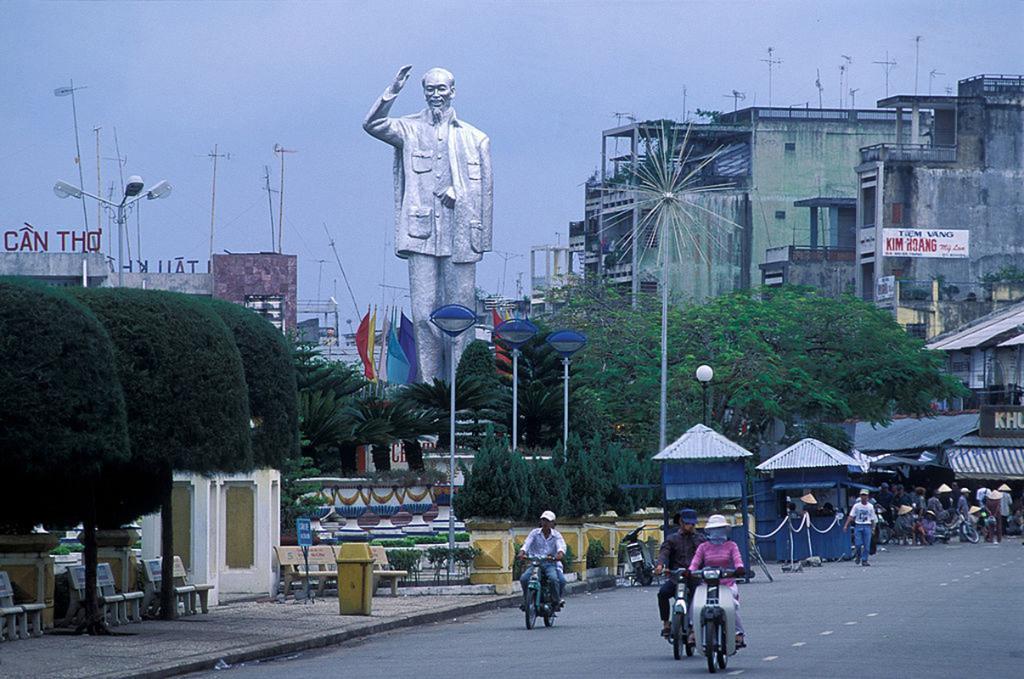Please provide a concise description of this image. This picture shows buildings and few people riding motorcycles and few of them wore caps on their heads and we see poles and we see few benches and a dustbin on the sidewalk and we see a statue and few flags and few pole lights and a cloudy Sky. 